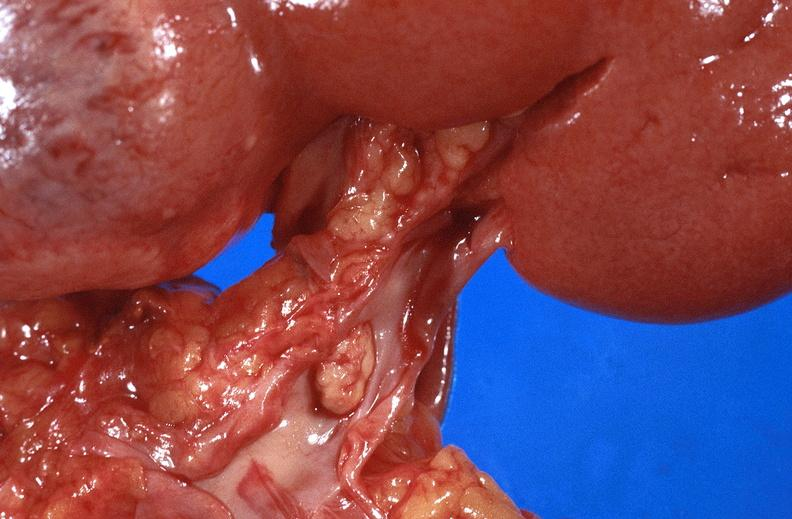does subdiaphragmatic abscess show renal cell carcinoma with extension into vena cava?
Answer the question using a single word or phrase. No 